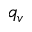Convert formula to latex. <formula><loc_0><loc_0><loc_500><loc_500>q _ { v }</formula> 